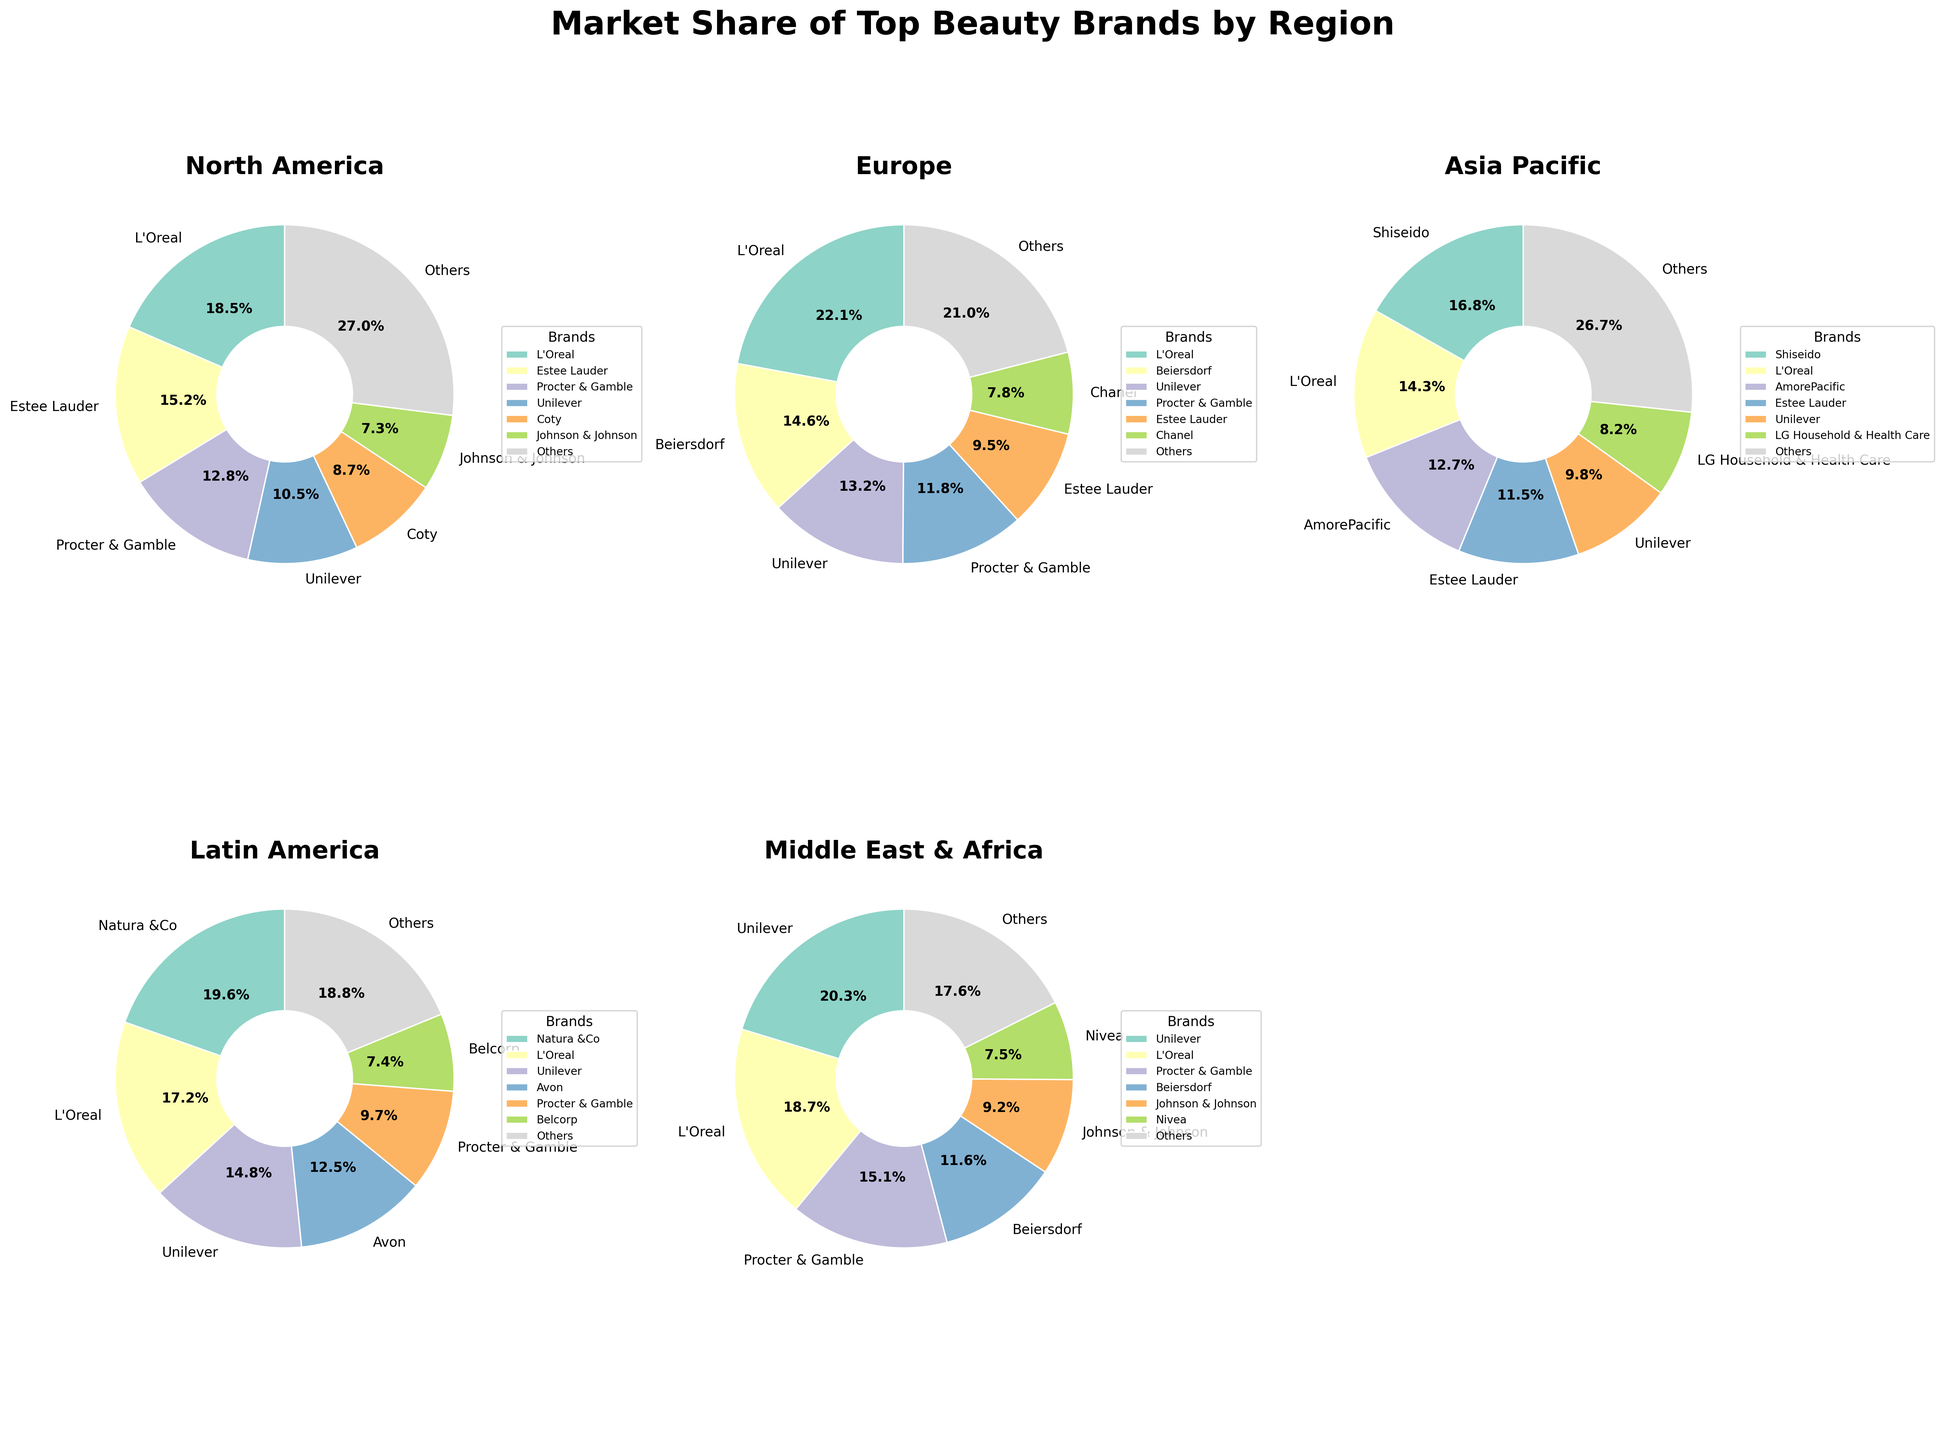What is the market share of L'Oreal in North America compared to Asia Pacific? First, locate the pie charts for North America and Asia Pacific. Then find the segment labeled "L'Oreal" in each pie chart. The market share of L'Oreal in North America is 18.5%, and in Asia Pacific, it is 14.3%. Compare these two values.
Answer: L'Oreal has a higher market share in North America (18.5%) than in Asia Pacific (14.3%) Which region has the highest market share for Unilever, and what is that share? Examine each pie chart and find the segment labeled "Unilever." Compare the market share percentages for Unilever across all regions: North America (10.5%), Europe (13.2%), Asia Pacific (9.8%), Latin America (14.8%), and Middle East & Africa (20.3%). The highest percentage is in the Middle East & Africa at 20.3%.
Answer: Middle East & Africa, 20.3% What is the combined market share of Procter & Gamble and Estee Lauder in Europe? Find the segments for Procter & Gamble and Estee Lauder in the Europe pie chart. The market share for Procter & Gamble is 11.8%, and for Estee Lauder is 9.5%. Add these two percentages together: 11.8% + 9.5% = 21.3%.
Answer: 21.3% Which brand has the smallest market share in Latin America and what is that share? Look at the pie chart for Latin America and identify the smallest segment. Belcorp has the smallest market share in Latin America, which is 7.4%.
Answer: Belcorp, 7.4% In which region does L'Oreal have the greatest market share, and what is the percentage difference between that region and the one where it has the smallest market share? Compare the market share of L'Oreal across all regions: North America (18.5%), Europe (22.1%), Asia Pacific (14.3%), Latin America (17.2%), Middle East & Africa (18.7%). The greatest share is in Europe (22.1%) and the smallest is in Asia Pacific (14.3%). The percentage difference is 22.1% - 14.3% = 7.8%.
Answer: Europe, 7.8% What is the market share of brands categorized as "Others" in Asia Pacific compared to North America? Locate the "Others" segment in both the Asia Pacific and North America pie charts. In Asia Pacific, "Others" has a market share of 26.7%, while in North America it is 27.0%. Compare these two values.
Answer: North America has a slightly higher market share for "Others" at 27.0% compared to Asia Pacific's 26.7% How does the market share of Shiseido in Asia Pacific compare with the market share of Natura &Co in Latin America? Find the segments for Shiseido in Asia Pacific and Natura &Co in Latin America. Shiseido has a market share of 16.8% in Asia Pacific, and Natura &Co has a market share of 19.6% in Latin America. Compare these values to determine that Natura &Co has a higher market share.
Answer: Natura &Co has a higher share at 19.6% compared to Shiseido's 16.8% 